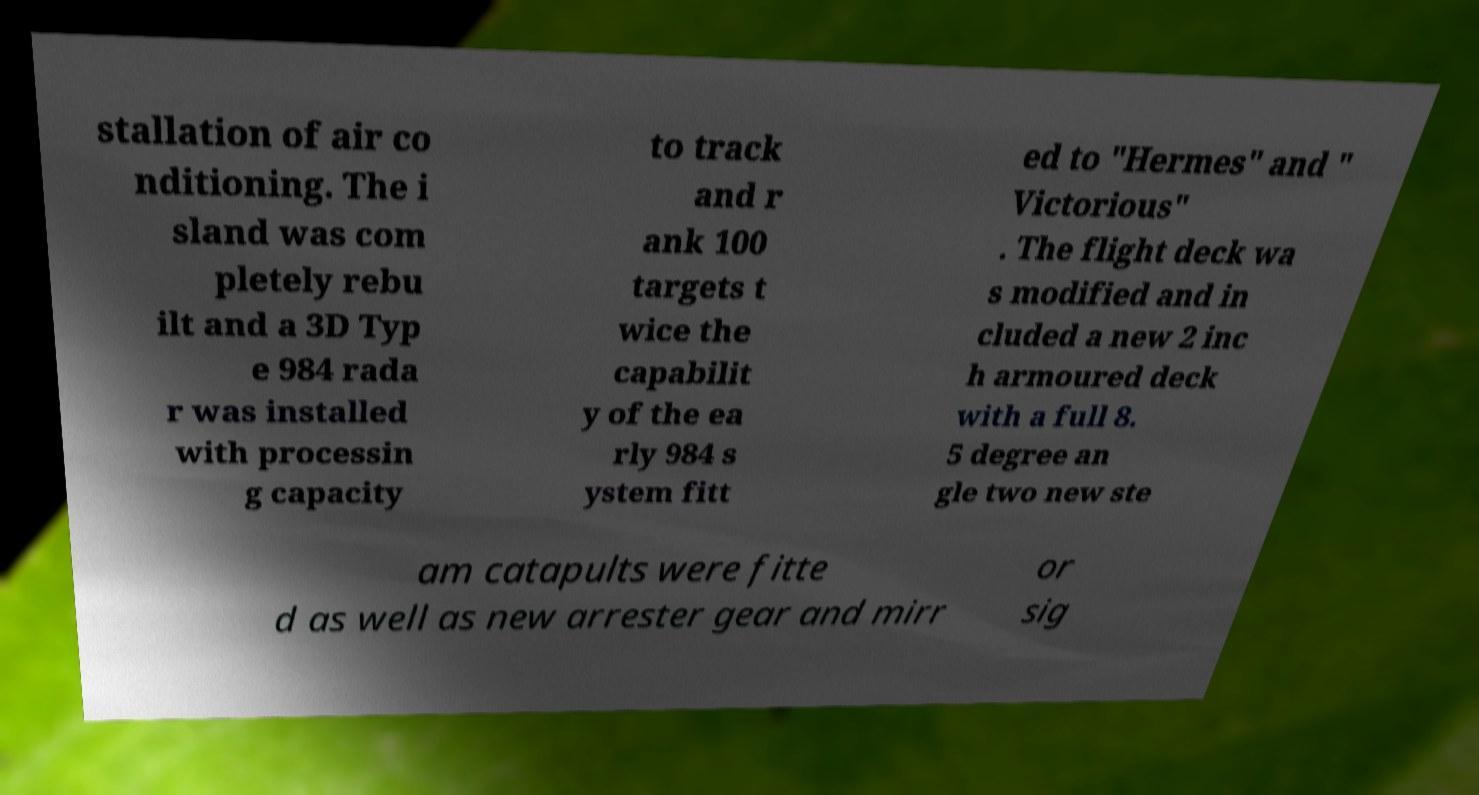Can you read and provide the text displayed in the image?This photo seems to have some interesting text. Can you extract and type it out for me? stallation of air co nditioning. The i sland was com pletely rebu ilt and a 3D Typ e 984 rada r was installed with processin g capacity to track and r ank 100 targets t wice the capabilit y of the ea rly 984 s ystem fitt ed to "Hermes" and " Victorious" . The flight deck wa s modified and in cluded a new 2 inc h armoured deck with a full 8. 5 degree an gle two new ste am catapults were fitte d as well as new arrester gear and mirr or sig 